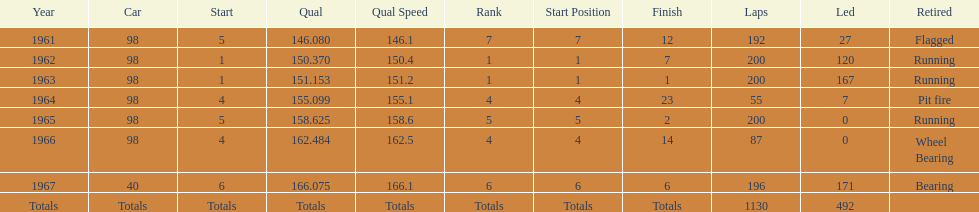Previous to 1965, when did jones have a number 5 start at the indy 500? 1961. 